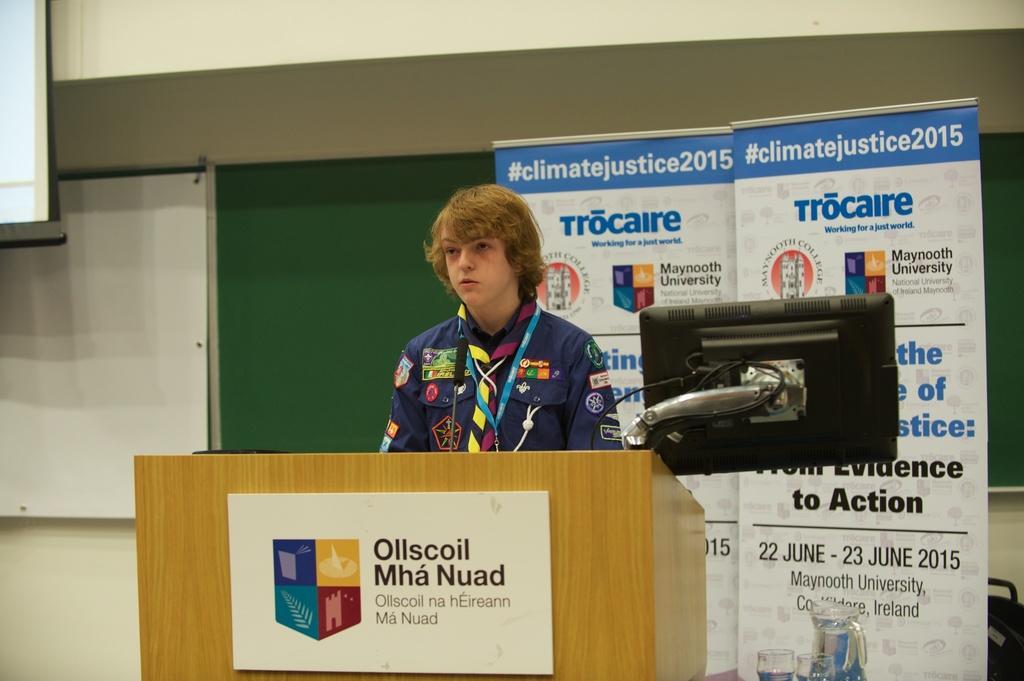Could you give a brief overview of what you see in this image? In this picture there is a person in the center of the image and there is a desk in front of him, there is a monitor on the right side of the image, there are posters and a board in the background area of the image and there is a projector screen in the top left side of the image. 